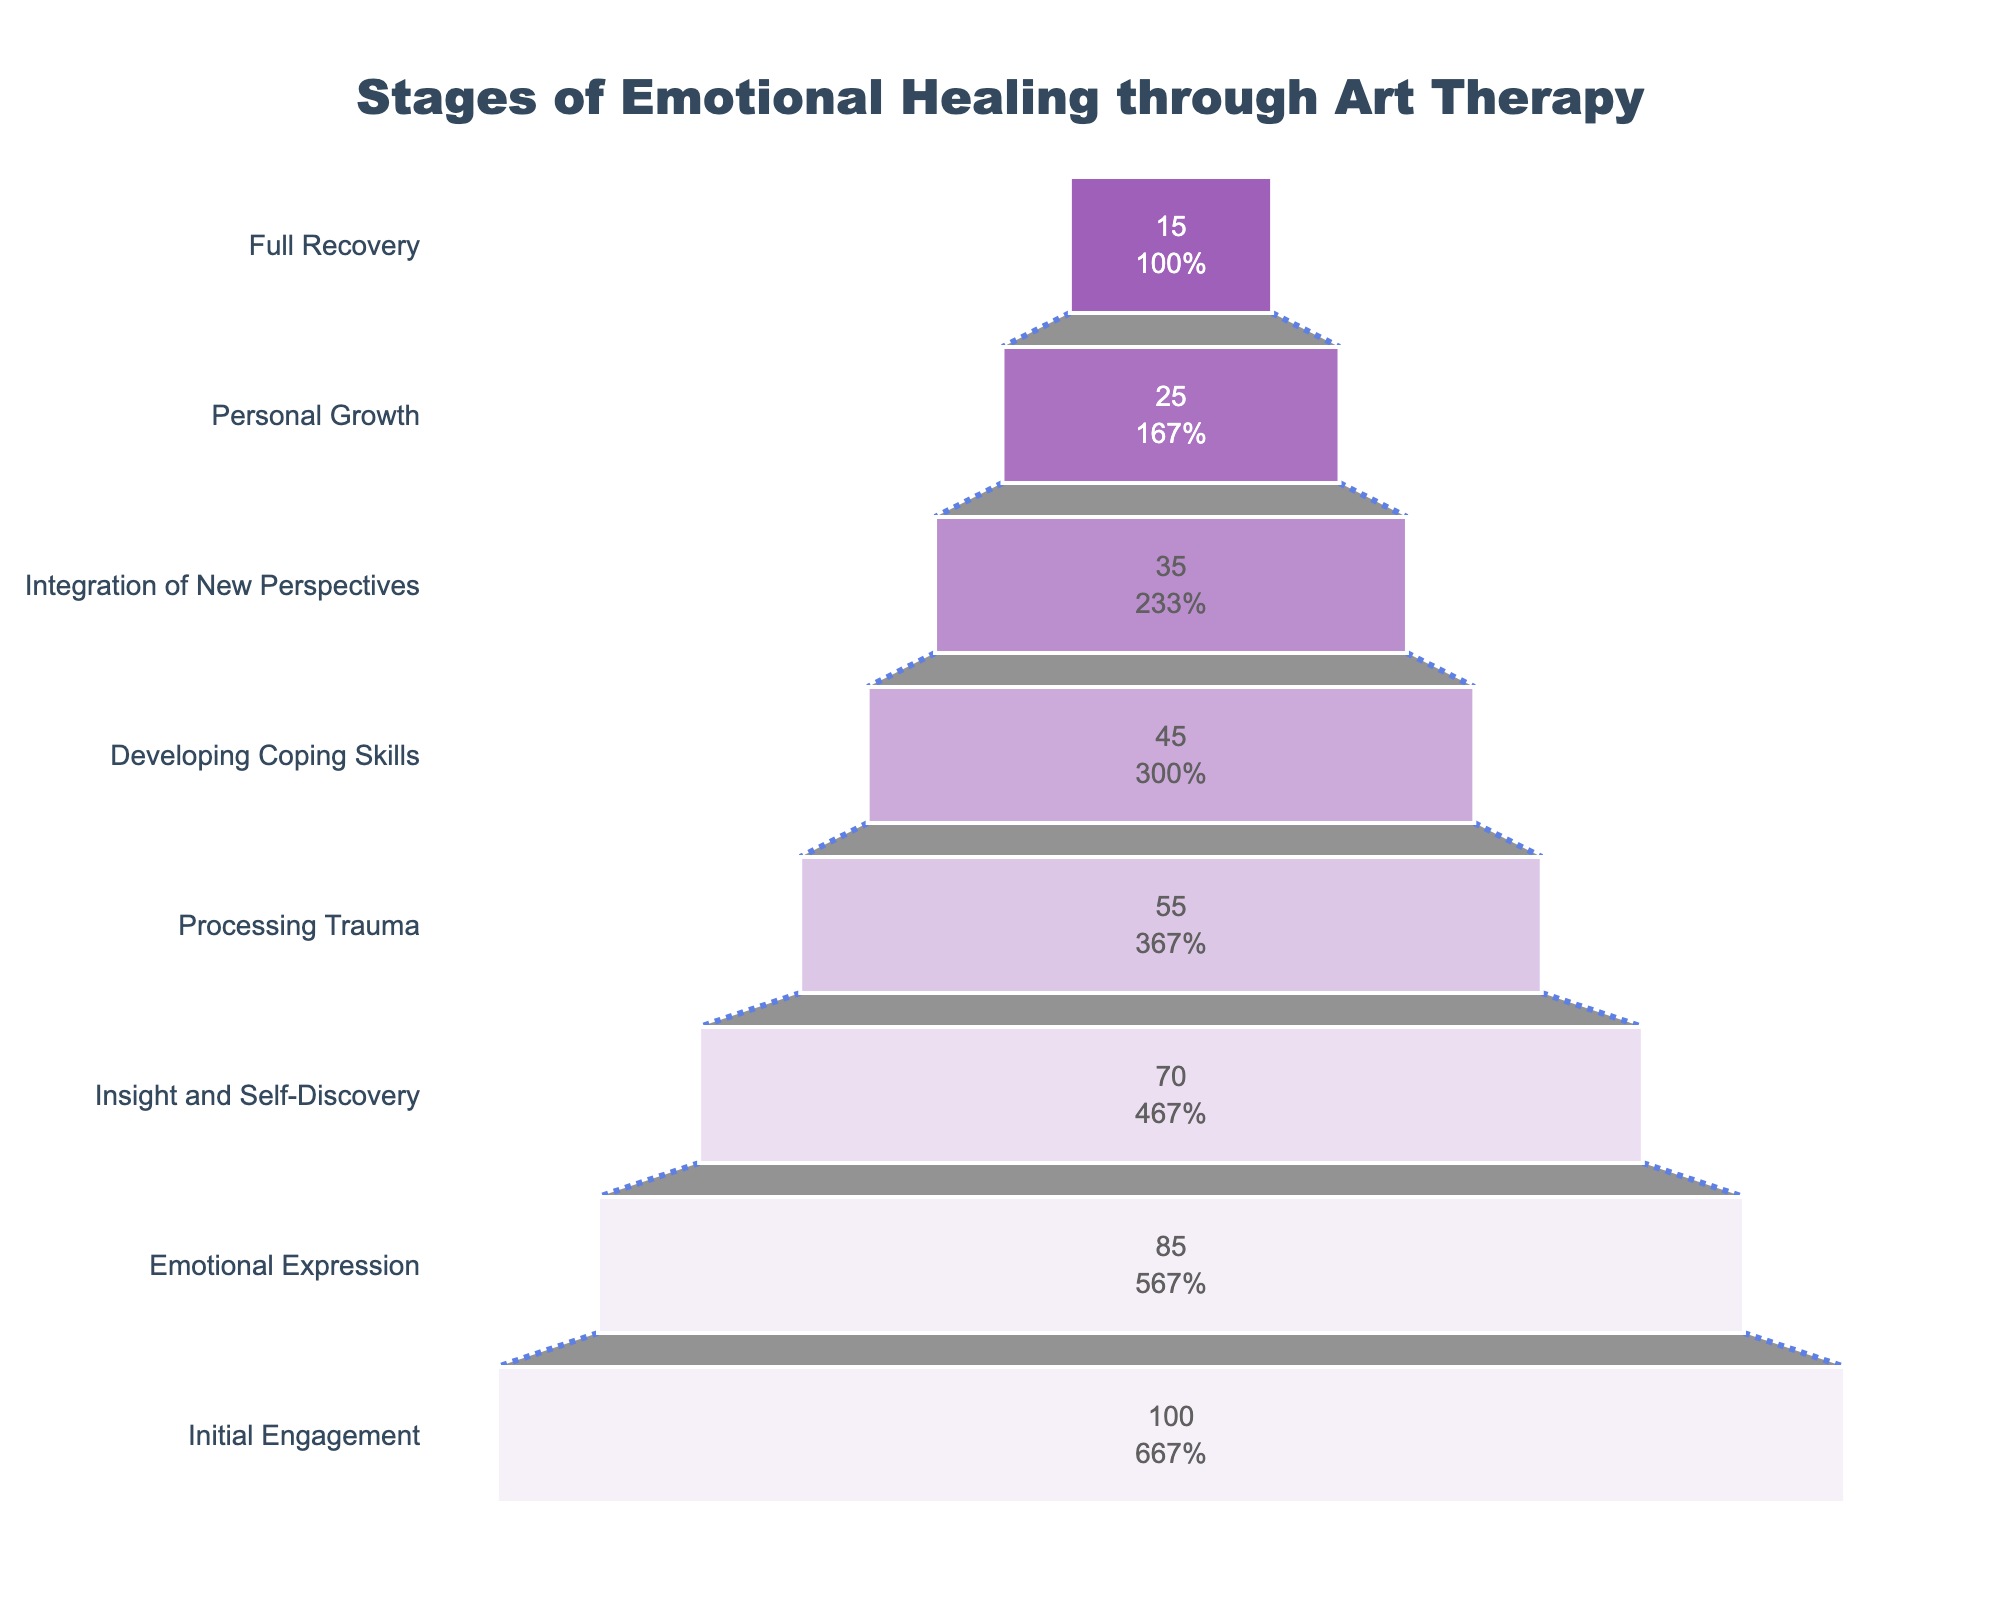What is the title of the funnel chart? The title of the funnel chart is located at the top of the figure, and it summarizes the whole plot.
Answer: Stages of Emotional Healing through Art Therapy How many participants are in the "Developing Coping Skills" stage? The number of participants in each stage is indicated by the horizontal bars. Look for the bar labeled "Developing Coping Skills" and read the value inside it.
Answer: 45 Which stage has the fewest participants? The fewest participants correspond to the smallest horizontal bar in the funnel. Identify the shortest bar and read the stage name.
Answer: Full Recovery What is the difference in the number of participants between the "Initial Engagement" and "Emotional Expression" stages? Subtract the number of participants in the "Emotional Expression" stage from the number of participants in the "Initial Engagement" stage.
Answer: 15 What percentage of the initial participants reach the "Personal Growth" stage? To find the percentage, divide the number of participants in the "Personal Growth" stage by the number of participants in the "Initial Engagement" stage and multiply by 100.
Answer: 25% At which stage do approximately half of the initial participants remain? Look for the stage where the number of participants is roughly half of the initial engagement count (around 50 participants).
Answer: Processing Trauma How many stages are there in total from initial engagement to full recovery? Count the number of horizontal bars from the start to the end of the chart.
Answer: 8 Which stage marks the transition to fewer than half of the initial participants being retained? Identify the stage just after which the number of participants is less than half of 100 (i.e., less than 50).
Answer: Developing Coping Skills What is the visual cue for connecting different stages in the funnel chart? Look for visual elements that link the horizontal bars; in this case, it is the connectors (dashed lines).
Answer: Dashed lines How many participants drop out between the "Insight and Self-Discovery" and "Processing Trauma" stages? Subtract the number of participants in the "Processing Trauma" stage from the number of participants in the "Insight and Self-Discovery" stage.
Answer: 15 